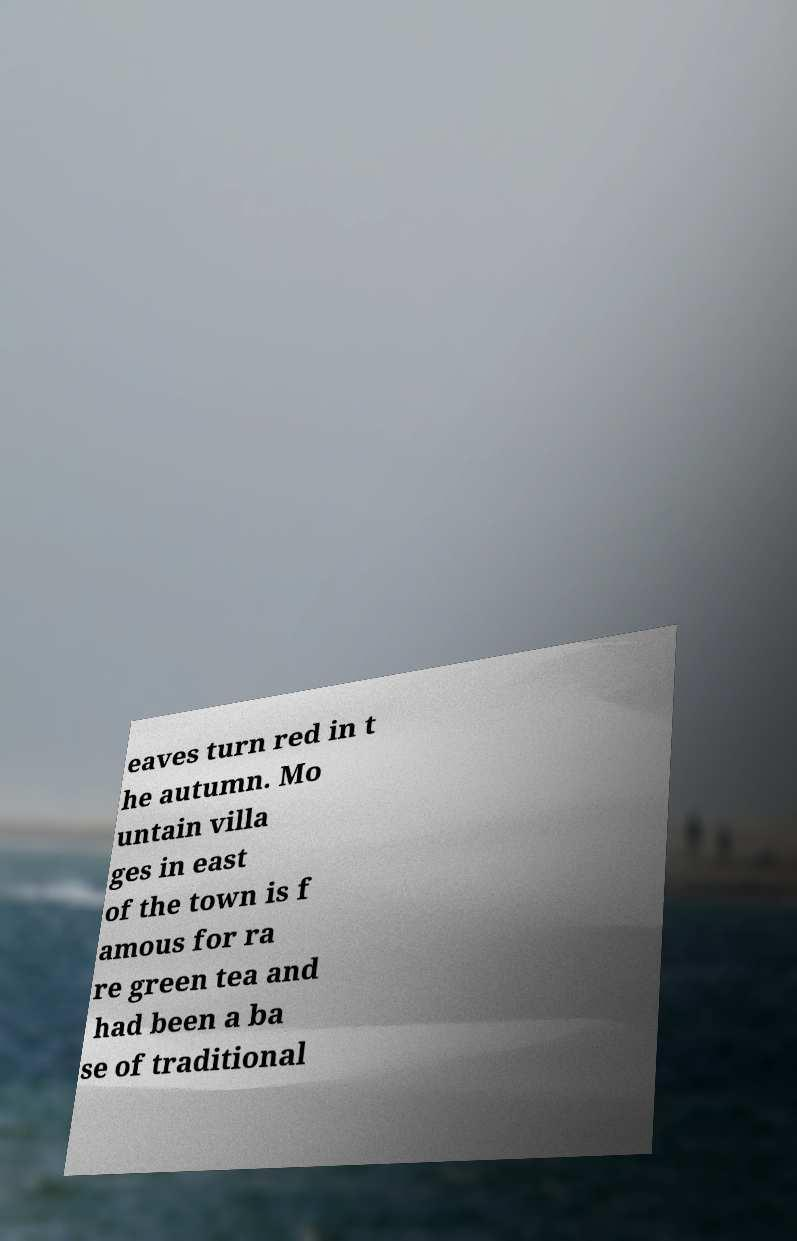For documentation purposes, I need the text within this image transcribed. Could you provide that? eaves turn red in t he autumn. Mo untain villa ges in east of the town is f amous for ra re green tea and had been a ba se of traditional 